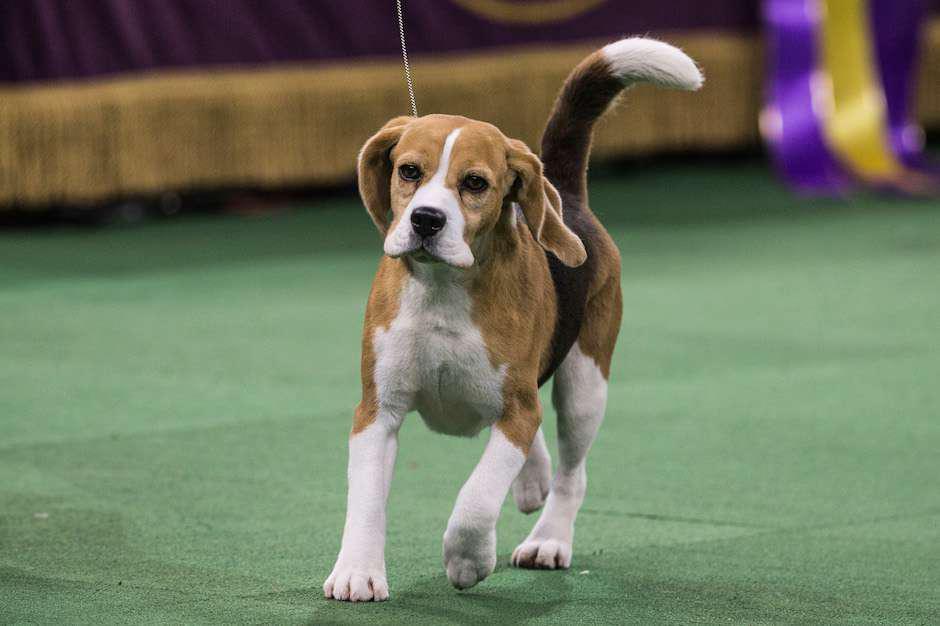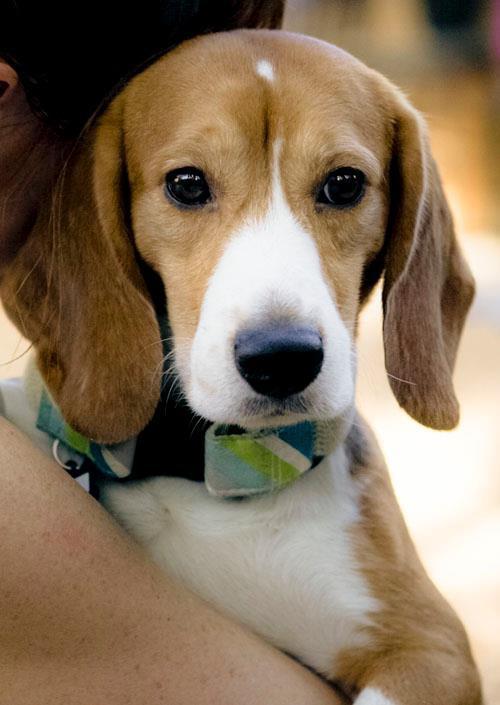The first image is the image on the left, the second image is the image on the right. Analyze the images presented: Is the assertion "There are no more than two dogs." valid? Answer yes or no. Yes. 